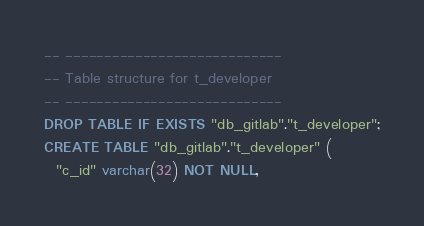<code> <loc_0><loc_0><loc_500><loc_500><_SQL_>

-- ----------------------------
-- Table structure for t_developer
-- ----------------------------
DROP TABLE IF EXISTS "db_gitlab"."t_developer";
CREATE TABLE "db_gitlab"."t_developer" (
  "c_id" varchar(32) NOT NULL,</code> 